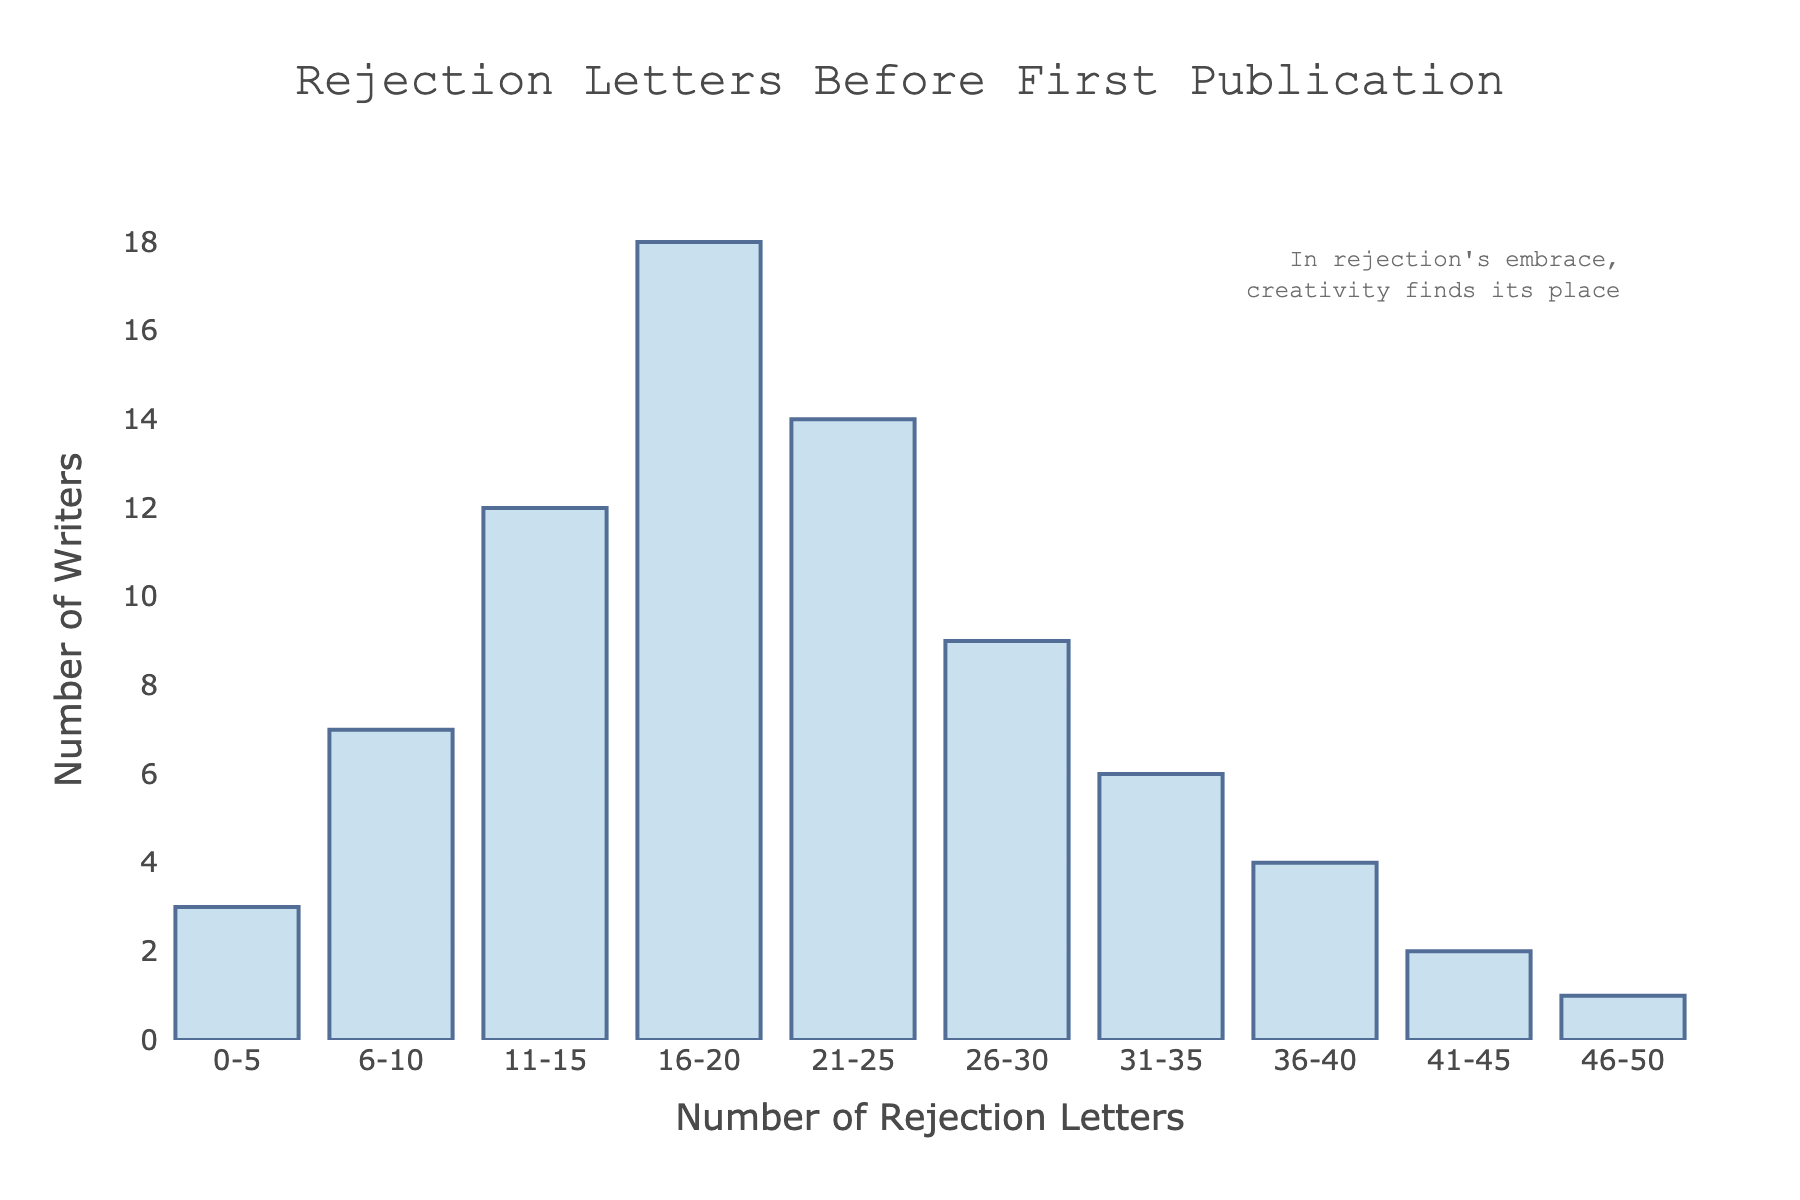What is the title of the histogram? The title is displayed at the top center of the histogram in larger font.
Answer: Rejection Letters Before First Publication How many writers received 0-5 rejection letters before their first publication? Look at the bar labeled "0-5" on the x-axis and observe its corresponding height on the y-axis.
Answer: 3 Which range of rejection letters has the highest number of writers? Identify the bar that has the tallest height among all in the chart.
Answer: 16-20 How many writers received between 26 and 30 rejection letters before their first publication? Look at the bar labeled "26-30" on the x-axis and observe its corresponding height on the y-axis.
Answer: 9 What is the total number of writers who received more than 40 rejection letters? Sum the heights of the bars labeled "41-45" and "46-50".
Answer: 3 How does the number of writers who received 31-35 rejection letters compare to those who received 6-10 rejection letters? Compare the heights of the bars labeled "31-35" and "6-10" on the x-axis.
Answer: Fewer What is the average number of writers across all rejection letter ranges? Sum the heights of all bars, then divide by the number of different ranges (10).
Answer: 7.6 How many more writers received 21-25 rejection letters compared to 41-45 rejection letters? Subtract the number of writers in the "41-45" range from the number in the "21-25" range.
Answer: 12 Are there any ranges of rejection letters where an equal number of writers received them? Check the heights of the bars and see if any bars have the same height.
Answer: No What is the difference in the number of writers between those who received 16-20 and 26-30 rejection letters? Subtract the number of writers in the "26-30" range from the number in the "16-20" range.
Answer: 9 